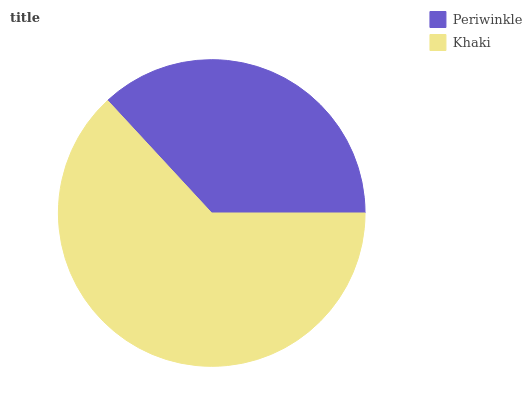Is Periwinkle the minimum?
Answer yes or no. Yes. Is Khaki the maximum?
Answer yes or no. Yes. Is Khaki the minimum?
Answer yes or no. No. Is Khaki greater than Periwinkle?
Answer yes or no. Yes. Is Periwinkle less than Khaki?
Answer yes or no. Yes. Is Periwinkle greater than Khaki?
Answer yes or no. No. Is Khaki less than Periwinkle?
Answer yes or no. No. Is Khaki the high median?
Answer yes or no. Yes. Is Periwinkle the low median?
Answer yes or no. Yes. Is Periwinkle the high median?
Answer yes or no. No. Is Khaki the low median?
Answer yes or no. No. 